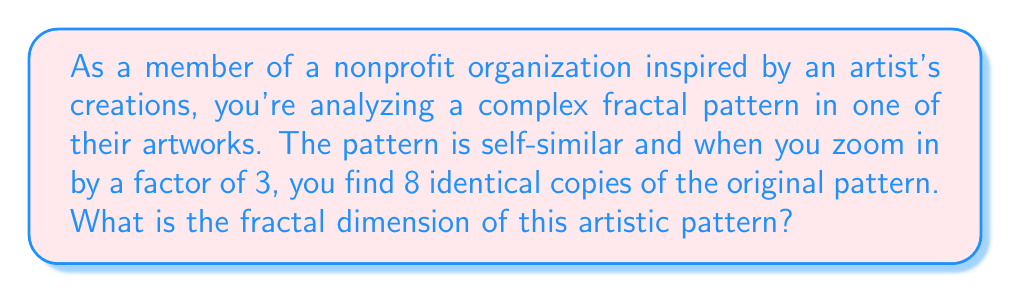Teach me how to tackle this problem. To find the fractal dimension of a self-similar pattern, we use the box-counting dimension formula:

$$ D = \frac{\log N}{\log S} $$

Where:
- $D$ is the fractal dimension
- $N$ is the number of self-similar pieces
- $S$ is the scaling factor

In this case:
- $N = 8$ (8 identical copies)
- $S = 3$ (zoom factor of 3)

Substituting these values into the formula:

$$ D = \frac{\log 8}{\log 3} $$

To calculate this:

$$ D = \frac{\log 8}{\log 3} = \frac{\log 2^3}{\log 3} = \frac{3 \log 2}{\log 3} \approx 1.8927 $$

The fractal dimension lies between 1 and 2, which is typical for many fractal patterns in 2D art. This non-integer dimension indicates the pattern's complexity, filling more space than a line (dimension 1) but less than a filled plane (dimension 2).
Answer: The fractal dimension of the artistic pattern is approximately 1.8927. 